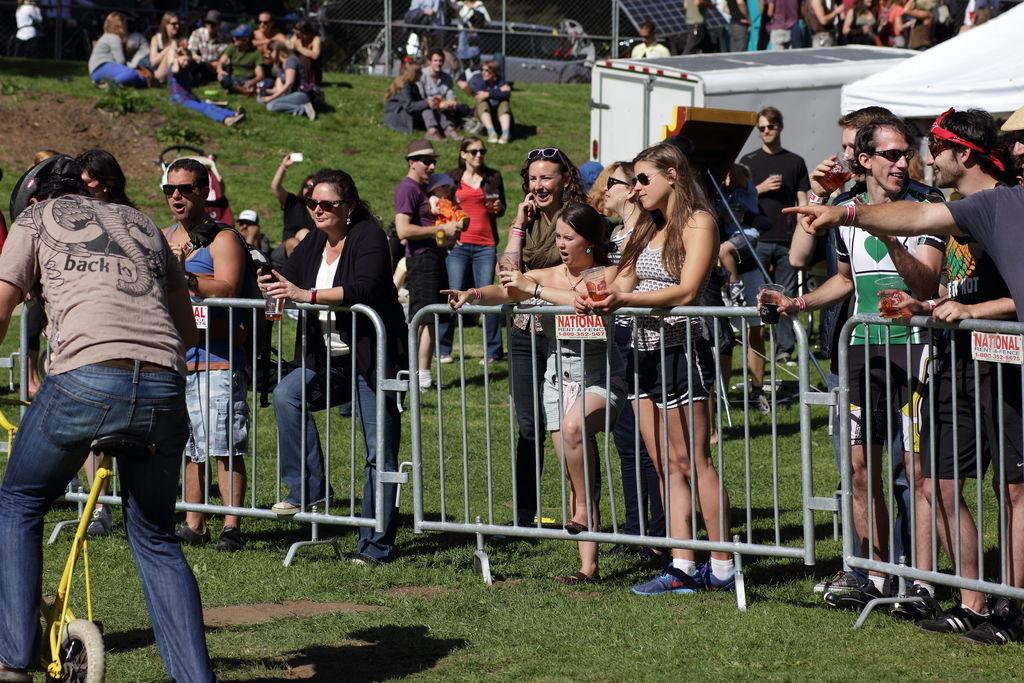Who is the main subject in the image? There is a man in the image. What is the man doing in the image? The man is riding a small bicycle. Are there any other people present in the image? Yes, there are people beside the man watching him. What type of sugar is being used to sweeten the plot in the image? There is no plot or sugar present in the image. 